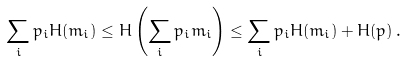Convert formula to latex. <formula><loc_0><loc_0><loc_500><loc_500>\sum _ { i } p _ { i } H ( m _ { i } ) \leq H \left ( \sum _ { i } p _ { i } m _ { i } \right ) \leq \sum _ { i } p _ { i } H ( m _ { i } ) + H ( p ) \, .</formula> 